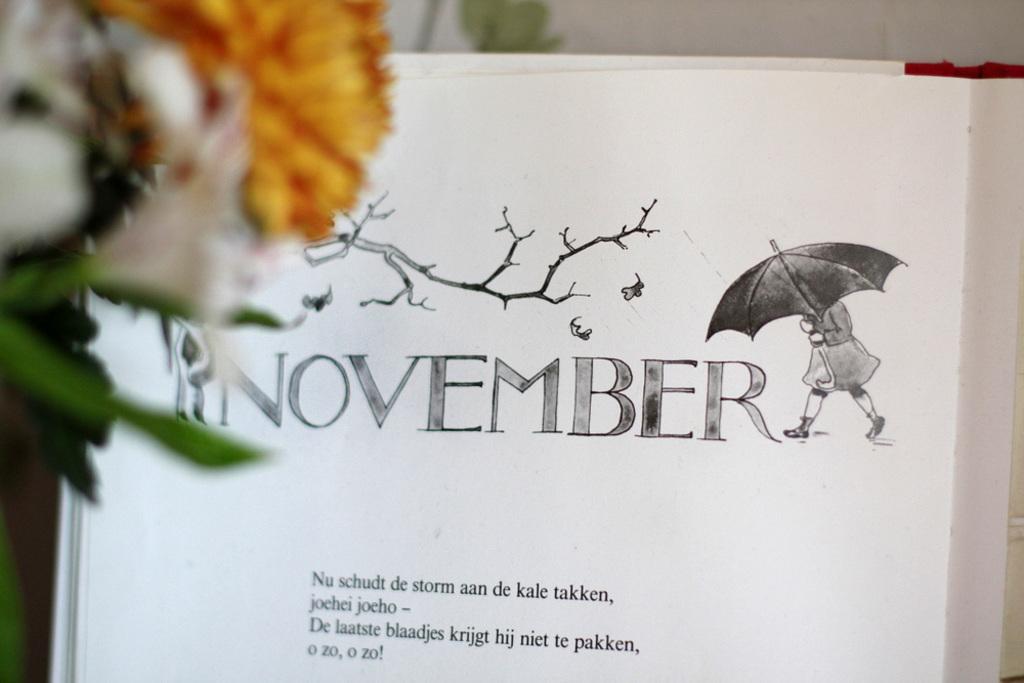Please provide a concise description of this image. In the image there is a flower plant on the left side with a book in the middle with some text on it. 